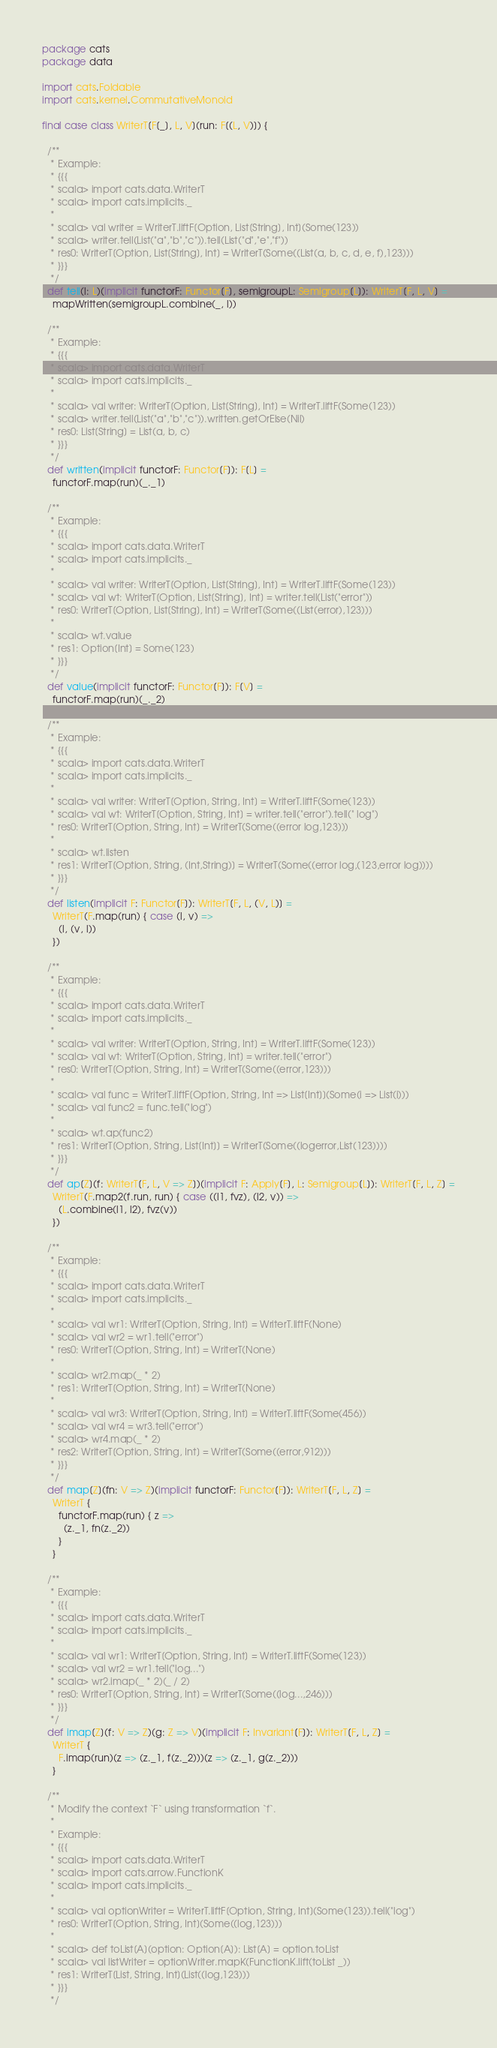<code> <loc_0><loc_0><loc_500><loc_500><_Scala_>package cats
package data

import cats.Foldable
import cats.kernel.CommutativeMonoid

final case class WriterT[F[_], L, V](run: F[(L, V)]) {

  /**
   * Example:
   * {{{
   * scala> import cats.data.WriterT
   * scala> import cats.implicits._
   *
   * scala> val writer = WriterT.liftF[Option, List[String], Int](Some(123))
   * scala> writer.tell(List("a","b","c")).tell(List("d","e","f"))
   * res0: WriterT[Option, List[String], Int] = WriterT(Some((List(a, b, c, d, e, f),123)))
   * }}}
   */
  def tell(l: L)(implicit functorF: Functor[F], semigroupL: Semigroup[L]): WriterT[F, L, V] =
    mapWritten(semigroupL.combine(_, l))

  /**
   * Example:
   * {{{
   * scala> import cats.data.WriterT
   * scala> import cats.implicits._
   *
   * scala> val writer: WriterT[Option, List[String], Int] = WriterT.liftF(Some(123))
   * scala> writer.tell(List("a","b","c")).written.getOrElse(Nil)
   * res0: List[String] = List(a, b, c)
   * }}}
   */
  def written(implicit functorF: Functor[F]): F[L] =
    functorF.map(run)(_._1)

  /**
   * Example:
   * {{{
   * scala> import cats.data.WriterT
   * scala> import cats.implicits._
   *
   * scala> val writer: WriterT[Option, List[String], Int] = WriterT.liftF(Some(123))
   * scala> val wt: WriterT[Option, List[String], Int] = writer.tell(List("error"))
   * res0: WriterT[Option, List[String], Int] = WriterT(Some((List(error),123)))
   *
   * scala> wt.value
   * res1: Option[Int] = Some(123)
   * }}}
   */
  def value(implicit functorF: Functor[F]): F[V] =
    functorF.map(run)(_._2)

  /**
   * Example:
   * {{{
   * scala> import cats.data.WriterT
   * scala> import cats.implicits._
   *
   * scala> val writer: WriterT[Option, String, Int] = WriterT.liftF(Some(123))
   * scala> val wt: WriterT[Option, String, Int] = writer.tell("error").tell(" log")
   * res0: WriterT[Option, String, Int] = WriterT(Some((error log,123)))
   *
   * scala> wt.listen
   * res1: WriterT[Option, String, (Int,String)] = WriterT(Some((error log,(123,error log))))
   * }}}
   */
  def listen(implicit F: Functor[F]): WriterT[F, L, (V, L)] =
    WriterT(F.map(run) { case (l, v) =>
      (l, (v, l))
    })

  /**
   * Example:
   * {{{
   * scala> import cats.data.WriterT
   * scala> import cats.implicits._
   *
   * scala> val writer: WriterT[Option, String, Int] = WriterT.liftF(Some(123))
   * scala> val wt: WriterT[Option, String, Int] = writer.tell("error")
   * res0: WriterT[Option, String, Int] = WriterT(Some((error,123)))
   *
   * scala> val func = WriterT.liftF[Option, String, Int => List[Int]](Some(i => List(i)))
   * scala> val func2 = func.tell("log")
   *
   * scala> wt.ap(func2)
   * res1: WriterT[Option, String, List[Int]] = WriterT(Some((logerror,List(123))))
   * }}}
   */
  def ap[Z](f: WriterT[F, L, V => Z])(implicit F: Apply[F], L: Semigroup[L]): WriterT[F, L, Z] =
    WriterT(F.map2(f.run, run) { case ((l1, fvz), (l2, v)) =>
      (L.combine(l1, l2), fvz(v))
    })

  /**
   * Example:
   * {{{
   * scala> import cats.data.WriterT
   * scala> import cats.implicits._
   *
   * scala> val wr1: WriterT[Option, String, Int] = WriterT.liftF(None)
   * scala> val wr2 = wr1.tell("error")
   * res0: WriterT[Option, String, Int] = WriterT(None)
   *
   * scala> wr2.map(_ * 2)
   * res1: WriterT[Option, String, Int] = WriterT(None)
   *
   * scala> val wr3: WriterT[Option, String, Int] = WriterT.liftF(Some(456))
   * scala> val wr4 = wr3.tell("error")
   * scala> wr4.map(_ * 2)
   * res2: WriterT[Option, String, Int] = WriterT(Some((error,912)))
   * }}}
   */
  def map[Z](fn: V => Z)(implicit functorF: Functor[F]): WriterT[F, L, Z] =
    WriterT {
      functorF.map(run) { z =>
        (z._1, fn(z._2))
      }
    }

  /**
   * Example:
   * {{{
   * scala> import cats.data.WriterT
   * scala> import cats.implicits._
   *
   * scala> val wr1: WriterT[Option, String, Int] = WriterT.liftF(Some(123))
   * scala> val wr2 = wr1.tell("log...")
   * scala> wr2.imap(_ * 2)(_ / 2)
   * res0: WriterT[Option, String, Int] = WriterT(Some((log...,246)))
   * }}}
   */
  def imap[Z](f: V => Z)(g: Z => V)(implicit F: Invariant[F]): WriterT[F, L, Z] =
    WriterT {
      F.imap(run)(z => (z._1, f(z._2)))(z => (z._1, g(z._2)))
    }

  /**
   * Modify the context `F` using transformation `f`.
   *
   * Example:
   * {{{
   * scala> import cats.data.WriterT
   * scala> import cats.arrow.FunctionK
   * scala> import cats.implicits._
   *
   * scala> val optionWriter = WriterT.liftF[Option, String, Int](Some(123)).tell("log")
   * res0: WriterT[Option, String, Int](Some((log,123)))
   *
   * scala> def toList[A](option: Option[A]): List[A] = option.toList
   * scala> val listWriter = optionWriter.mapK(FunctionK.lift(toList _))
   * res1: WriterT[List, String, Int](List((log,123)))
   * }}}
   */</code> 